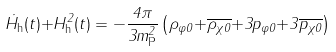Convert formula to latex. <formula><loc_0><loc_0><loc_500><loc_500>\dot { H } _ { \text {h} } ( t ) { + } H _ { \text {h} } ^ { 2 } ( t ) = { - } \frac { 4 \pi } { 3 m ^ { 2 } _ { \text {P} } } \left ( \rho _ { \varphi 0 } { + } \overline { \rho _ { \chi 0 } } { + } 3 p _ { \varphi 0 } { + } 3 \overline { p _ { \chi 0 } } \right )</formula> 